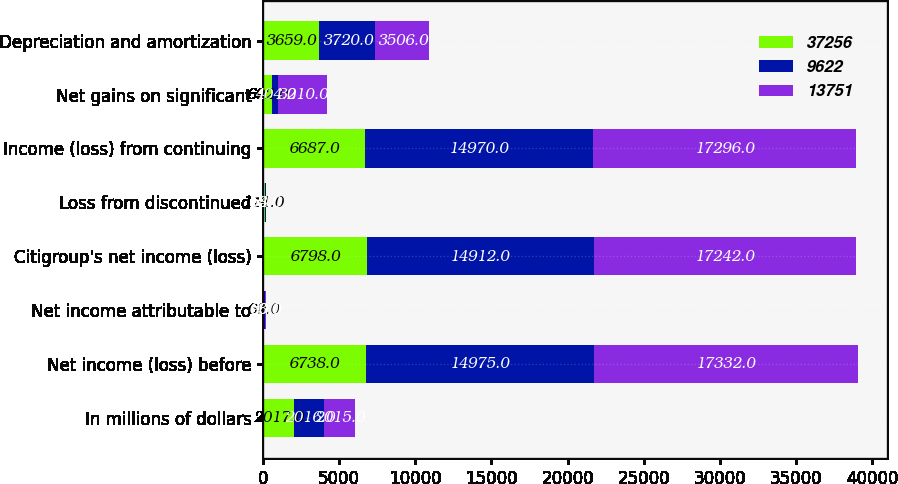Convert chart to OTSL. <chart><loc_0><loc_0><loc_500><loc_500><stacked_bar_chart><ecel><fcel>In millions of dollars<fcel>Net income (loss) before<fcel>Net income attributable to<fcel>Citigroup's net income (loss)<fcel>Loss from discontinued<fcel>Income (loss) from continuing<fcel>Net gains on significant<fcel>Depreciation and amortization<nl><fcel>37256<fcel>2017<fcel>6738<fcel>60<fcel>6798<fcel>111<fcel>6687<fcel>602<fcel>3659<nl><fcel>9622<fcel>2016<fcel>14975<fcel>63<fcel>14912<fcel>58<fcel>14970<fcel>404<fcel>3720<nl><fcel>13751<fcel>2015<fcel>17332<fcel>90<fcel>17242<fcel>54<fcel>17296<fcel>3210<fcel>3506<nl></chart> 